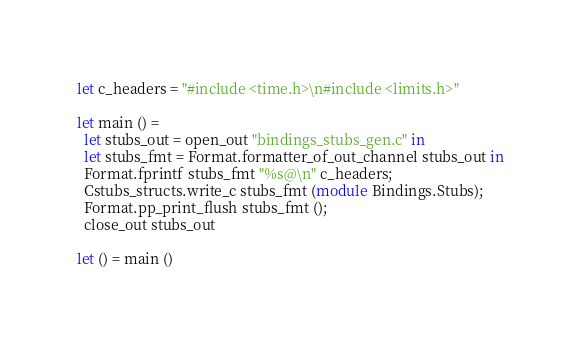<code> <loc_0><loc_0><loc_500><loc_500><_OCaml_>let c_headers = "#include <time.h>\n#include <limits.h>"

let main () =
  let stubs_out = open_out "bindings_stubs_gen.c" in
  let stubs_fmt = Format.formatter_of_out_channel stubs_out in
  Format.fprintf stubs_fmt "%s@\n" c_headers;
  Cstubs_structs.write_c stubs_fmt (module Bindings.Stubs);
  Format.pp_print_flush stubs_fmt ();
  close_out stubs_out

let () = main ()

</code> 